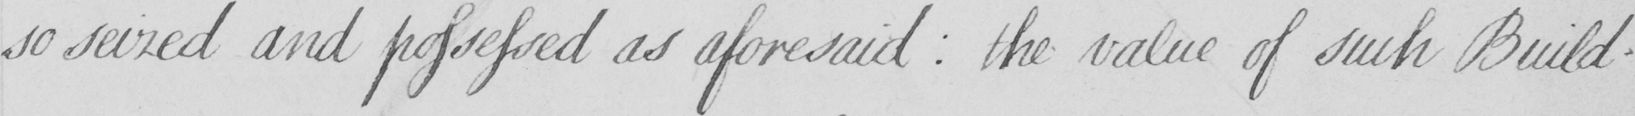Can you tell me what this handwritten text says? so seized and possessed as aforesaid : the value of such Build- 